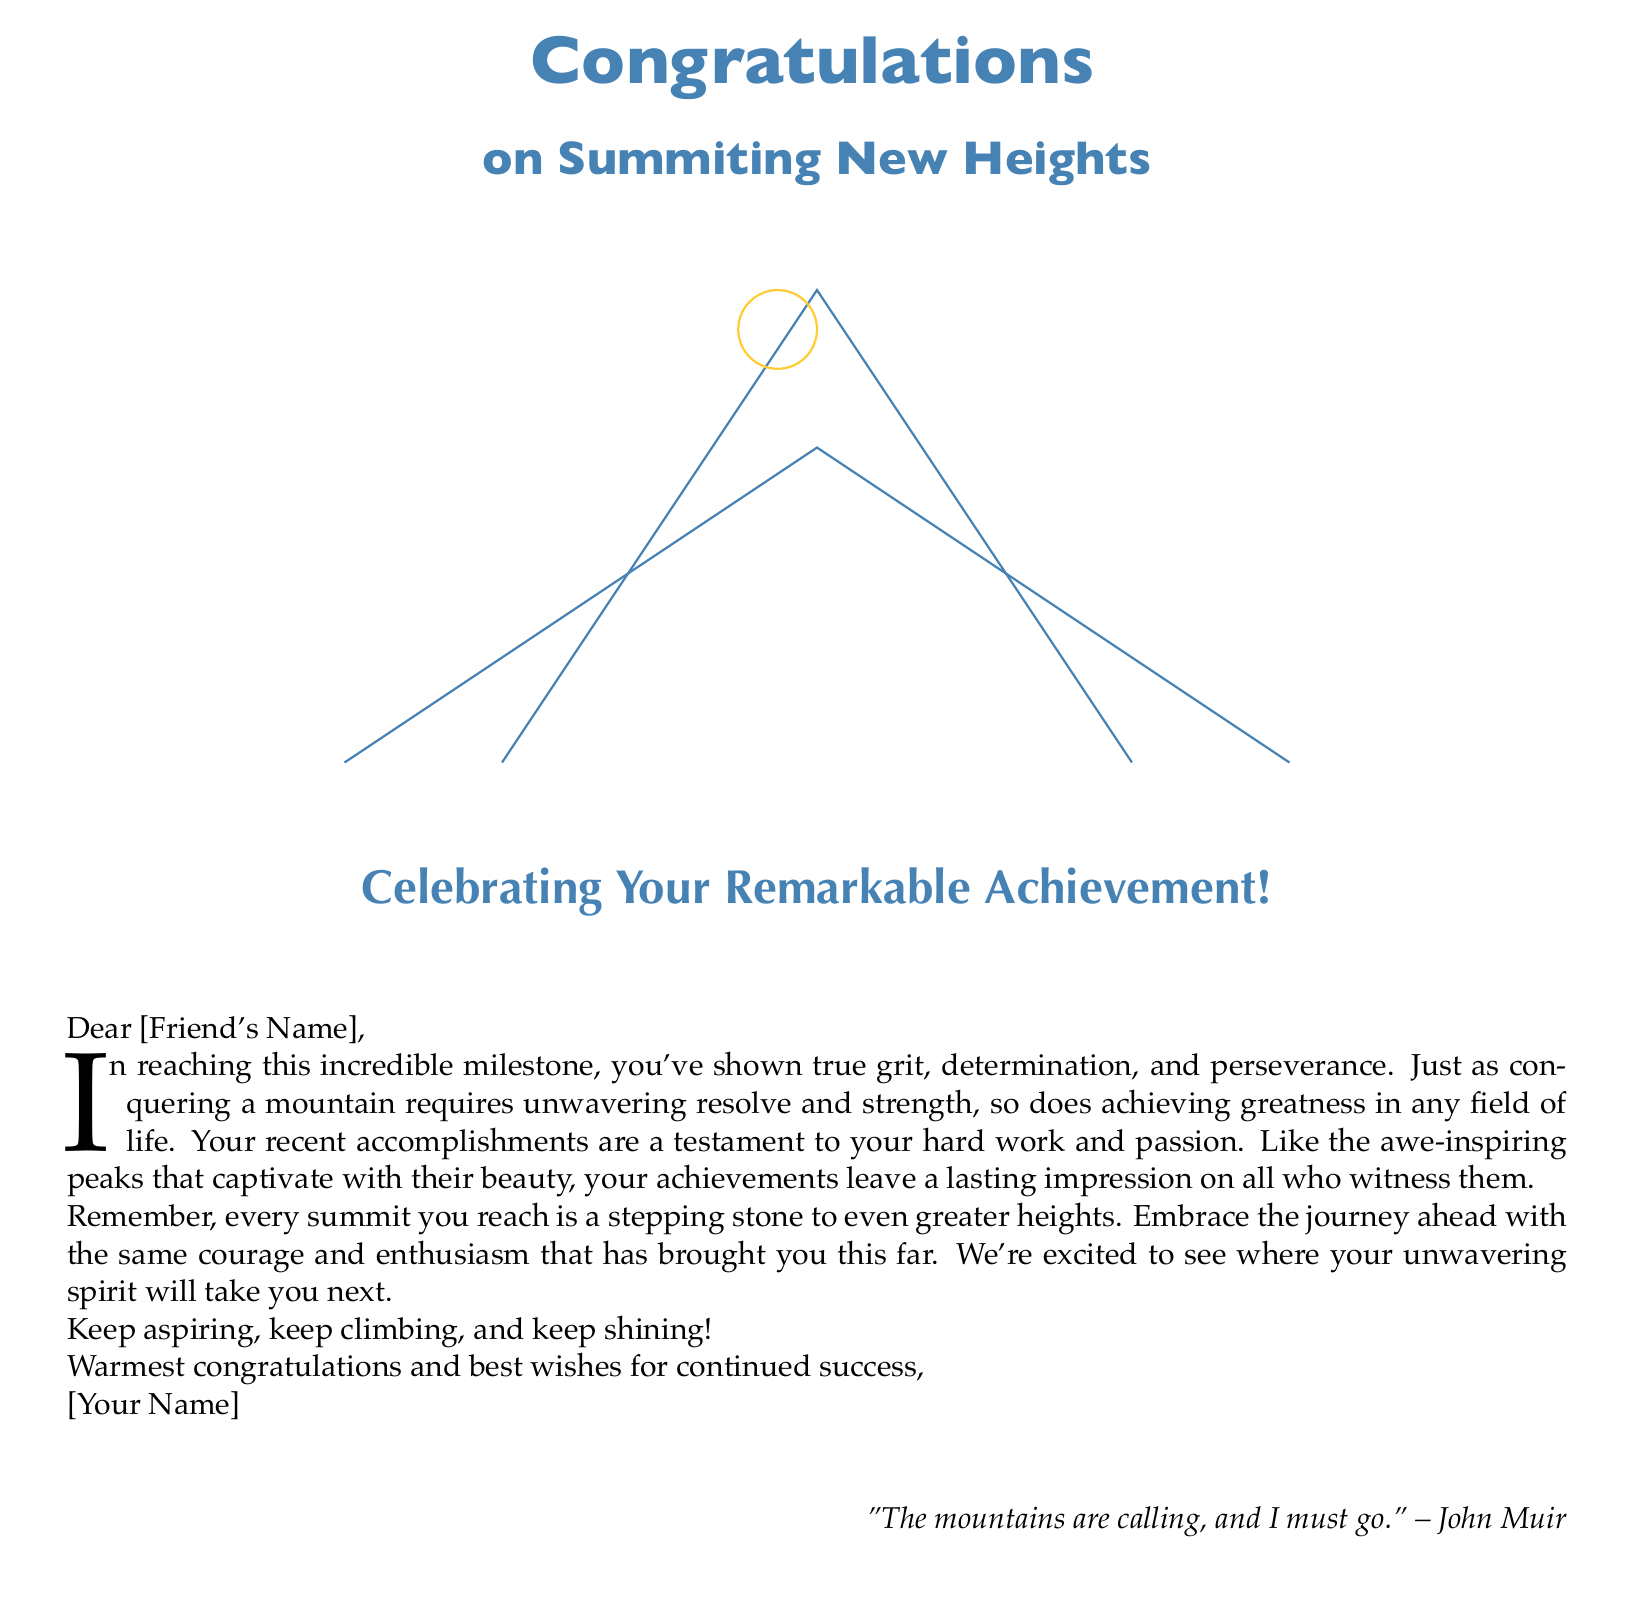What is the main color used on the cover? The main color used on the cover is specified in the document as mountain blue.
Answer: mountain blue Who is the greeting card addressed to? The greeting card is addressed to [Friend's Name], which is a placeholder for the recipient's name.
Answer: [Friend's Name] What is the first word in the letter? The first word in the letter is "In," which is the initial word of the heartfelt note.
Answer: In What famous quote is included in the card? A quote attributed to John Muir is included in the card, reflecting a love for nature and mountains.
Answer: "The mountains are calling, and I must go." What does the interior message encourage the recipient to do? The interior message encourages the recipient to keep aspiring, keep climbing, and keep shining.
Answer: keep aspiring, keep climbing, and keep shining What design element is featured in the card's cover? The cover features a design element of a mountain peak with a sun in the shape of a circle.
Answer: a mountain peak with a sun How many peaks are depicted in the mountain illustration? The mountain illustration includes a total of three peaks as drawn in the tikzpicture.
Answer: three peaks What theme does the card primarily celebrate? The card primarily celebrates the achievement of summiting new heights, applicable in both hiking and life.
Answer: summiting new heights 